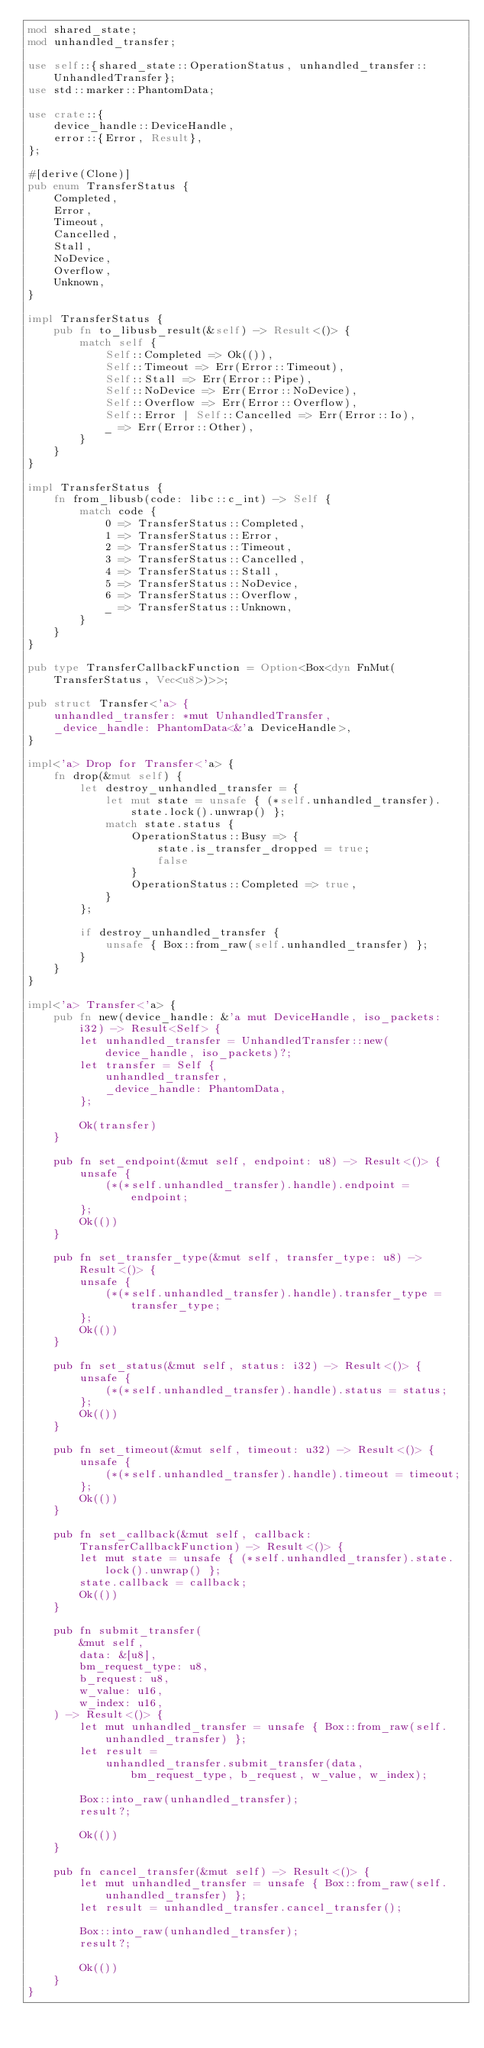Convert code to text. <code><loc_0><loc_0><loc_500><loc_500><_Rust_>mod shared_state;
mod unhandled_transfer;

use self::{shared_state::OperationStatus, unhandled_transfer::UnhandledTransfer};
use std::marker::PhantomData;

use crate::{
    device_handle::DeviceHandle,
    error::{Error, Result},
};

#[derive(Clone)]
pub enum TransferStatus {
    Completed,
    Error,
    Timeout,
    Cancelled,
    Stall,
    NoDevice,
    Overflow,
    Unknown,
}

impl TransferStatus {
    pub fn to_libusb_result(&self) -> Result<()> {
        match self {
            Self::Completed => Ok(()),
            Self::Timeout => Err(Error::Timeout),
            Self::Stall => Err(Error::Pipe),
            Self::NoDevice => Err(Error::NoDevice),
            Self::Overflow => Err(Error::Overflow),
            Self::Error | Self::Cancelled => Err(Error::Io),
            _ => Err(Error::Other),
        }
    }
}

impl TransferStatus {
    fn from_libusb(code: libc::c_int) -> Self {
        match code {
            0 => TransferStatus::Completed,
            1 => TransferStatus::Error,
            2 => TransferStatus::Timeout,
            3 => TransferStatus::Cancelled,
            4 => TransferStatus::Stall,
            5 => TransferStatus::NoDevice,
            6 => TransferStatus::Overflow,
            _ => TransferStatus::Unknown,
        }
    }
}

pub type TransferCallbackFunction = Option<Box<dyn FnMut(TransferStatus, Vec<u8>)>>;

pub struct Transfer<'a> {
    unhandled_transfer: *mut UnhandledTransfer,
    _device_handle: PhantomData<&'a DeviceHandle>,
}

impl<'a> Drop for Transfer<'a> {
    fn drop(&mut self) {
        let destroy_unhandled_transfer = {
            let mut state = unsafe { (*self.unhandled_transfer).state.lock().unwrap() };
            match state.status {
                OperationStatus::Busy => {
                    state.is_transfer_dropped = true;
                    false
                }
                OperationStatus::Completed => true,
            }
        };

        if destroy_unhandled_transfer {
            unsafe { Box::from_raw(self.unhandled_transfer) };
        }
    }
}

impl<'a> Transfer<'a> {
    pub fn new(device_handle: &'a mut DeviceHandle, iso_packets: i32) -> Result<Self> {
        let unhandled_transfer = UnhandledTransfer::new(device_handle, iso_packets)?;
        let transfer = Self {
            unhandled_transfer,
            _device_handle: PhantomData,
        };

        Ok(transfer)
    }

    pub fn set_endpoint(&mut self, endpoint: u8) -> Result<()> {
        unsafe {
            (*(*self.unhandled_transfer).handle).endpoint = endpoint;
        };
        Ok(())
    }

    pub fn set_transfer_type(&mut self, transfer_type: u8) -> Result<()> {
        unsafe {
            (*(*self.unhandled_transfer).handle).transfer_type = transfer_type;
        };
        Ok(())
    }

    pub fn set_status(&mut self, status: i32) -> Result<()> {
        unsafe {
            (*(*self.unhandled_transfer).handle).status = status;
        };
        Ok(())
    }

    pub fn set_timeout(&mut self, timeout: u32) -> Result<()> {
        unsafe {
            (*(*self.unhandled_transfer).handle).timeout = timeout;
        };
        Ok(())
    }

    pub fn set_callback(&mut self, callback: TransferCallbackFunction) -> Result<()> {
        let mut state = unsafe { (*self.unhandled_transfer).state.lock().unwrap() };
        state.callback = callback;
        Ok(())
    }

    pub fn submit_transfer(
        &mut self,
        data: &[u8],
        bm_request_type: u8,
        b_request: u8,
        w_value: u16,
        w_index: u16,
    ) -> Result<()> {
        let mut unhandled_transfer = unsafe { Box::from_raw(self.unhandled_transfer) };
        let result =
            unhandled_transfer.submit_transfer(data, bm_request_type, b_request, w_value, w_index);

        Box::into_raw(unhandled_transfer);
        result?;

        Ok(())
    }

    pub fn cancel_transfer(&mut self) -> Result<()> {
        let mut unhandled_transfer = unsafe { Box::from_raw(self.unhandled_transfer) };
        let result = unhandled_transfer.cancel_transfer();

        Box::into_raw(unhandled_transfer);
        result?;

        Ok(())
    }
}
</code> 